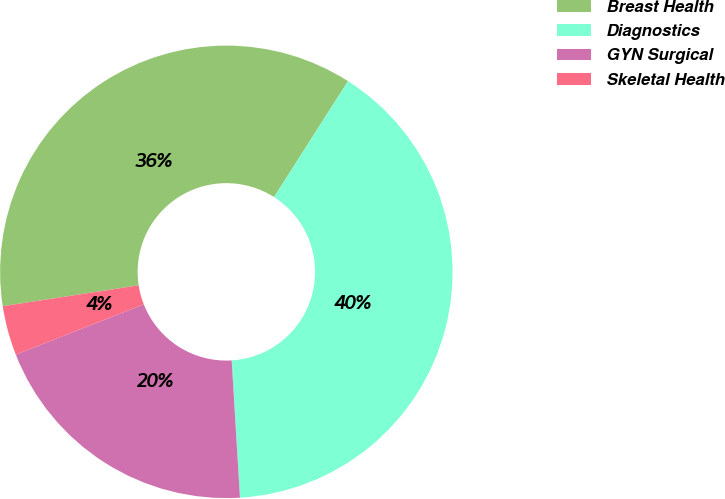Convert chart to OTSL. <chart><loc_0><loc_0><loc_500><loc_500><pie_chart><fcel>Breast Health<fcel>Diagnostics<fcel>GYN Surgical<fcel>Skeletal Health<nl><fcel>36.47%<fcel>40.0%<fcel>20.0%<fcel>3.53%<nl></chart> 